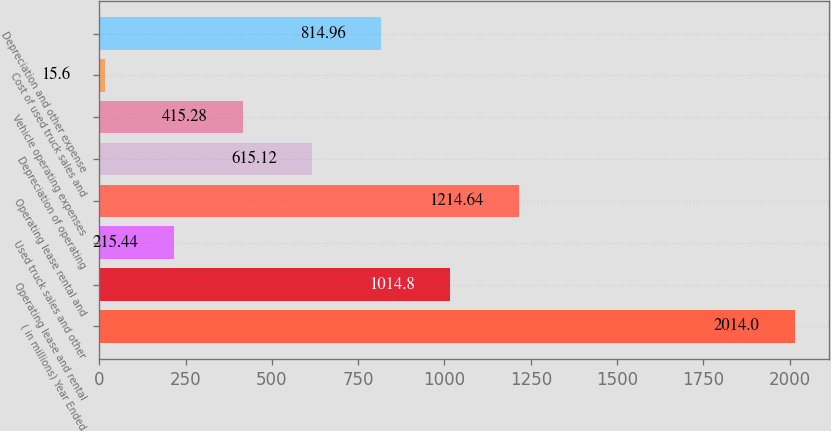Convert chart. <chart><loc_0><loc_0><loc_500><loc_500><bar_chart><fcel>( in millions) Year Ended<fcel>Operating lease and rental<fcel>Used truck sales and other<fcel>Operating lease rental and<fcel>Depreciation of operating<fcel>Vehicle operating expenses<fcel>Cost of used truck sales and<fcel>Depreciation and other expense<nl><fcel>2014<fcel>1014.8<fcel>215.44<fcel>1214.64<fcel>615.12<fcel>415.28<fcel>15.6<fcel>814.96<nl></chart> 